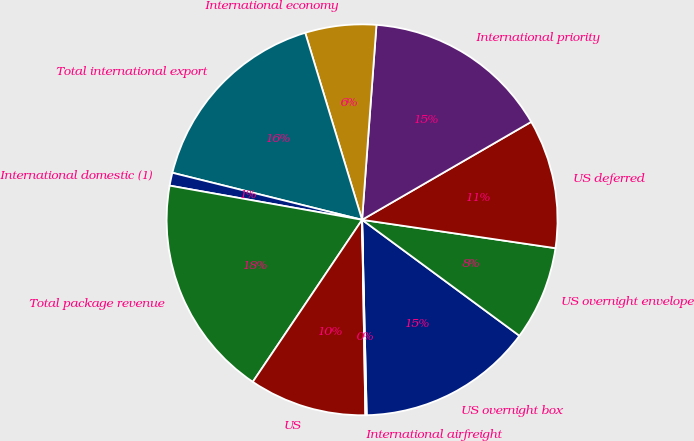Convert chart. <chart><loc_0><loc_0><loc_500><loc_500><pie_chart><fcel>US overnight box<fcel>US overnight envelope<fcel>US deferred<fcel>International priority<fcel>International economy<fcel>Total international export<fcel>International domestic (1)<fcel>Total package revenue<fcel>US<fcel>International airfreight<nl><fcel>14.51%<fcel>7.79%<fcel>10.67%<fcel>15.47%<fcel>5.87%<fcel>16.43%<fcel>1.07%<fcel>18.35%<fcel>9.71%<fcel>0.11%<nl></chart> 